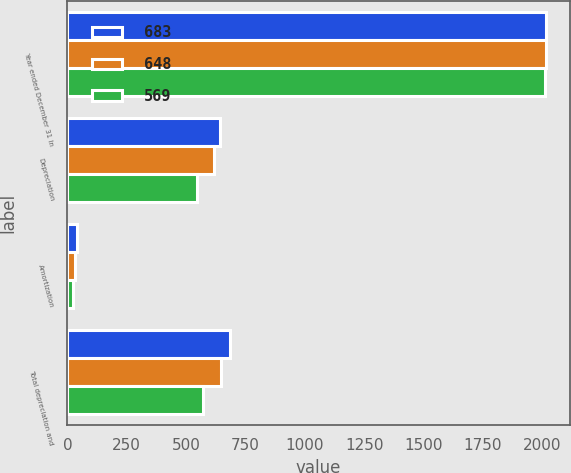Convert chart to OTSL. <chart><loc_0><loc_0><loc_500><loc_500><stacked_bar_chart><ecel><fcel>Year ended December 31 In<fcel>Depreciation<fcel>Amortization<fcel>Total depreciation and<nl><fcel>683<fcel>2015<fcel>643<fcel>40<fcel>683<nl><fcel>648<fcel>2014<fcel>618<fcel>30<fcel>648<nl><fcel>569<fcel>2013<fcel>546<fcel>23<fcel>569<nl></chart> 